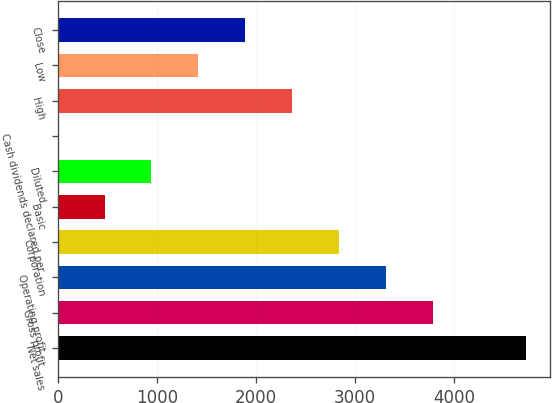Convert chart to OTSL. <chart><loc_0><loc_0><loc_500><loc_500><bar_chart><fcel>Net sales<fcel>Gross profit<fcel>Operating profit<fcel>Corporation<fcel>Basic<fcel>Diluted<fcel>Cash dividends declared per<fcel>High<fcel>Low<fcel>Close<nl><fcel>4727<fcel>3781.72<fcel>3309.08<fcel>2836.44<fcel>473.24<fcel>945.88<fcel>0.6<fcel>2363.8<fcel>1418.52<fcel>1891.16<nl></chart> 